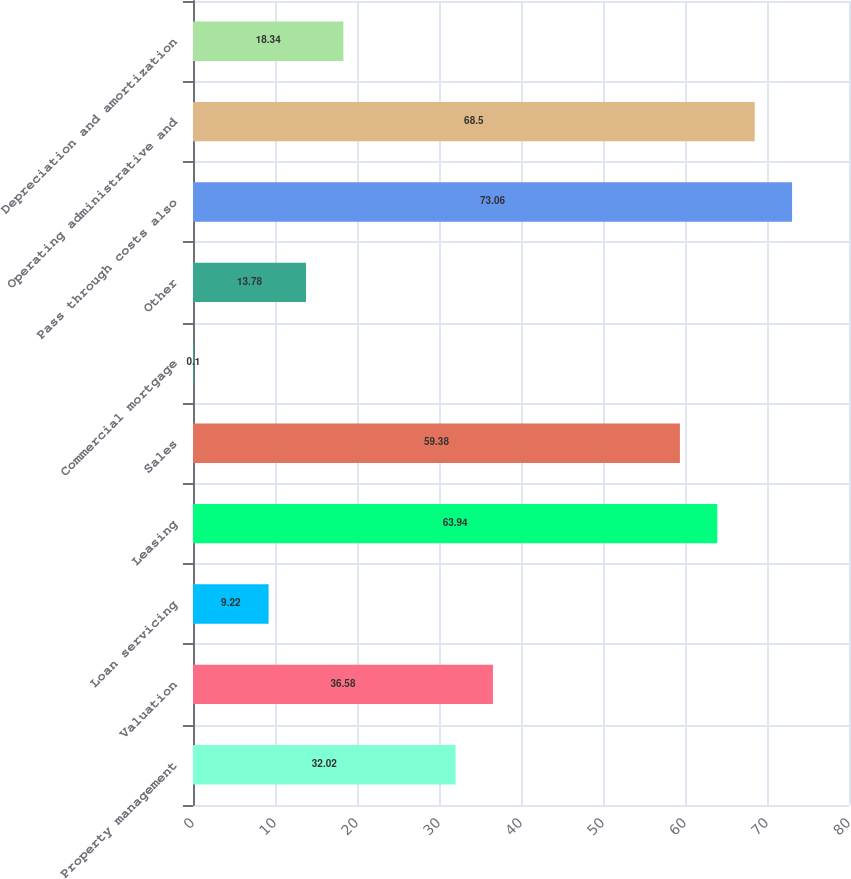Convert chart to OTSL. <chart><loc_0><loc_0><loc_500><loc_500><bar_chart><fcel>Property management<fcel>Valuation<fcel>Loan servicing<fcel>Leasing<fcel>Sales<fcel>Commercial mortgage<fcel>Other<fcel>Pass through costs also<fcel>Operating administrative and<fcel>Depreciation and amortization<nl><fcel>32.02<fcel>36.58<fcel>9.22<fcel>63.94<fcel>59.38<fcel>0.1<fcel>13.78<fcel>73.06<fcel>68.5<fcel>18.34<nl></chart> 